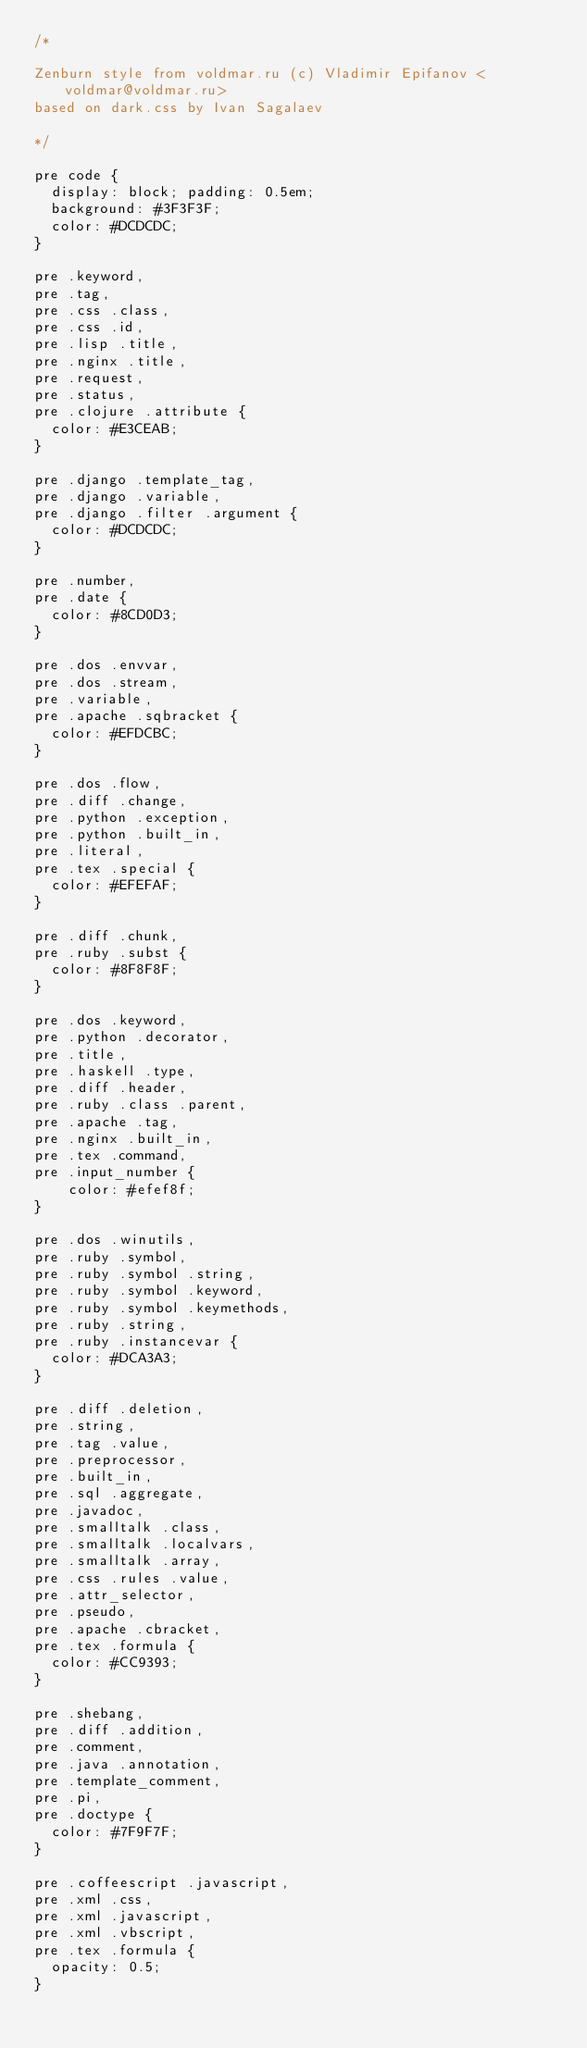Convert code to text. <code><loc_0><loc_0><loc_500><loc_500><_CSS_>/*

Zenburn style from voldmar.ru (c) Vladimir Epifanov <voldmar@voldmar.ru>
based on dark.css by Ivan Sagalaev

*/

pre code {
  display: block; padding: 0.5em;
  background: #3F3F3F;
  color: #DCDCDC;
}

pre .keyword,
pre .tag,
pre .css .class,
pre .css .id,
pre .lisp .title,
pre .nginx .title,
pre .request,
pre .status,
pre .clojure .attribute {
  color: #E3CEAB;
}

pre .django .template_tag,
pre .django .variable,
pre .django .filter .argument {
  color: #DCDCDC;
}

pre .number,
pre .date {
  color: #8CD0D3;
}

pre .dos .envvar,
pre .dos .stream,
pre .variable,
pre .apache .sqbracket {
  color: #EFDCBC;
}

pre .dos .flow,
pre .diff .change,
pre .python .exception,
pre .python .built_in,
pre .literal,
pre .tex .special {
  color: #EFEFAF;
}

pre .diff .chunk,
pre .ruby .subst {
  color: #8F8F8F;
}

pre .dos .keyword,
pre .python .decorator,
pre .title,
pre .haskell .type,
pre .diff .header,
pre .ruby .class .parent,
pre .apache .tag,
pre .nginx .built_in,
pre .tex .command,
pre .input_number {
    color: #efef8f;
}

pre .dos .winutils,
pre .ruby .symbol,
pre .ruby .symbol .string,
pre .ruby .symbol .keyword,
pre .ruby .symbol .keymethods,
pre .ruby .string,
pre .ruby .instancevar {
  color: #DCA3A3;
}

pre .diff .deletion,
pre .string,
pre .tag .value,
pre .preprocessor,
pre .built_in,
pre .sql .aggregate,
pre .javadoc,
pre .smalltalk .class,
pre .smalltalk .localvars,
pre .smalltalk .array,
pre .css .rules .value,
pre .attr_selector,
pre .pseudo,
pre .apache .cbracket,
pre .tex .formula {
  color: #CC9393;
}

pre .shebang,
pre .diff .addition,
pre .comment,
pre .java .annotation,
pre .template_comment,
pre .pi,
pre .doctype {
  color: #7F9F7F;
}

pre .coffeescript .javascript,
pre .xml .css,
pre .xml .javascript,
pre .xml .vbscript,
pre .tex .formula {
  opacity: 0.5;
}

</code> 